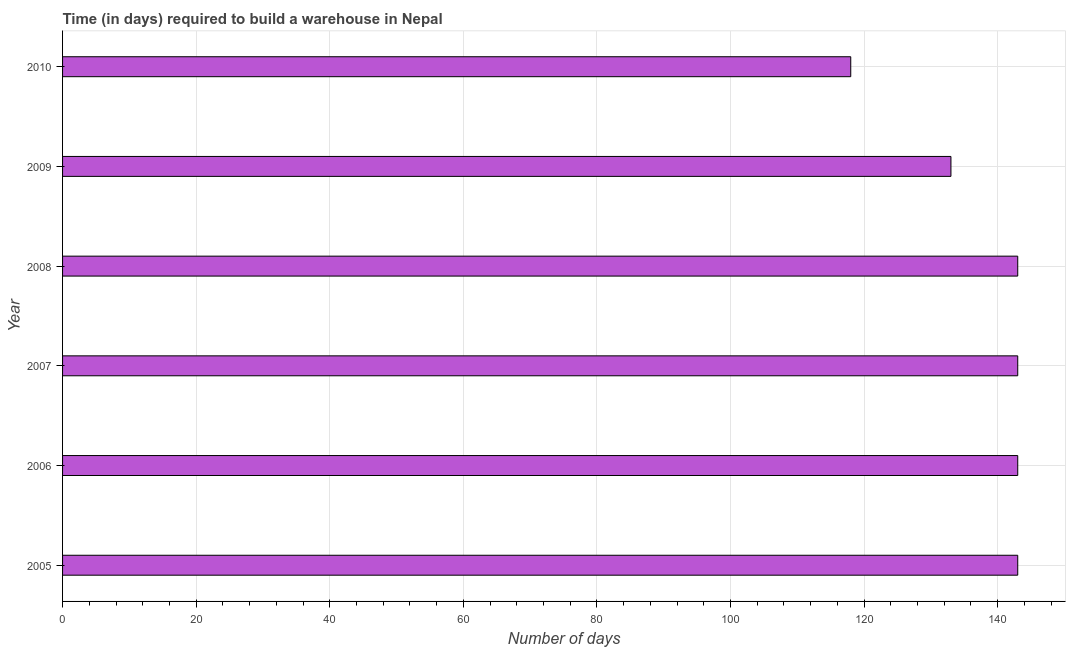Does the graph contain any zero values?
Keep it short and to the point. No. What is the title of the graph?
Your answer should be compact. Time (in days) required to build a warehouse in Nepal. What is the label or title of the X-axis?
Provide a short and direct response. Number of days. What is the time required to build a warehouse in 2005?
Provide a succinct answer. 143. Across all years, what is the maximum time required to build a warehouse?
Ensure brevity in your answer.  143. Across all years, what is the minimum time required to build a warehouse?
Ensure brevity in your answer.  118. What is the sum of the time required to build a warehouse?
Offer a terse response. 823. What is the difference between the time required to build a warehouse in 2005 and 2009?
Make the answer very short. 10. What is the average time required to build a warehouse per year?
Offer a terse response. 137. What is the median time required to build a warehouse?
Your response must be concise. 143. Do a majority of the years between 2009 and 2007 (inclusive) have time required to build a warehouse greater than 8 days?
Ensure brevity in your answer.  Yes. What is the ratio of the time required to build a warehouse in 2005 to that in 2006?
Provide a short and direct response. 1. Is the time required to build a warehouse in 2005 less than that in 2006?
Ensure brevity in your answer.  No. Is the difference between the time required to build a warehouse in 2007 and 2008 greater than the difference between any two years?
Provide a succinct answer. No. What is the difference between the highest and the second highest time required to build a warehouse?
Make the answer very short. 0. Is the sum of the time required to build a warehouse in 2005 and 2008 greater than the maximum time required to build a warehouse across all years?
Provide a short and direct response. Yes. How many bars are there?
Your answer should be compact. 6. How many years are there in the graph?
Provide a succinct answer. 6. What is the Number of days in 2005?
Your answer should be compact. 143. What is the Number of days of 2006?
Offer a terse response. 143. What is the Number of days in 2007?
Give a very brief answer. 143. What is the Number of days of 2008?
Your response must be concise. 143. What is the Number of days of 2009?
Offer a terse response. 133. What is the Number of days of 2010?
Offer a very short reply. 118. What is the difference between the Number of days in 2005 and 2008?
Make the answer very short. 0. What is the difference between the Number of days in 2005 and 2009?
Ensure brevity in your answer.  10. What is the difference between the Number of days in 2005 and 2010?
Ensure brevity in your answer.  25. What is the difference between the Number of days in 2006 and 2009?
Offer a terse response. 10. What is the difference between the Number of days in 2007 and 2008?
Provide a succinct answer. 0. What is the difference between the Number of days in 2007 and 2010?
Offer a terse response. 25. What is the difference between the Number of days in 2008 and 2009?
Your response must be concise. 10. What is the ratio of the Number of days in 2005 to that in 2006?
Offer a very short reply. 1. What is the ratio of the Number of days in 2005 to that in 2008?
Offer a terse response. 1. What is the ratio of the Number of days in 2005 to that in 2009?
Your response must be concise. 1.07. What is the ratio of the Number of days in 2005 to that in 2010?
Provide a short and direct response. 1.21. What is the ratio of the Number of days in 2006 to that in 2007?
Provide a succinct answer. 1. What is the ratio of the Number of days in 2006 to that in 2008?
Offer a terse response. 1. What is the ratio of the Number of days in 2006 to that in 2009?
Your answer should be very brief. 1.07. What is the ratio of the Number of days in 2006 to that in 2010?
Provide a succinct answer. 1.21. What is the ratio of the Number of days in 2007 to that in 2009?
Provide a short and direct response. 1.07. What is the ratio of the Number of days in 2007 to that in 2010?
Your answer should be compact. 1.21. What is the ratio of the Number of days in 2008 to that in 2009?
Make the answer very short. 1.07. What is the ratio of the Number of days in 2008 to that in 2010?
Your response must be concise. 1.21. What is the ratio of the Number of days in 2009 to that in 2010?
Provide a short and direct response. 1.13. 